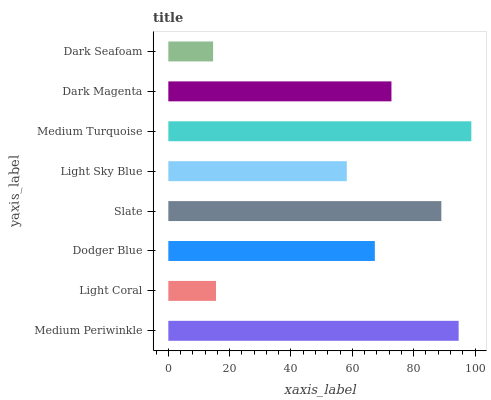Is Dark Seafoam the minimum?
Answer yes or no. Yes. Is Medium Turquoise the maximum?
Answer yes or no. Yes. Is Light Coral the minimum?
Answer yes or no. No. Is Light Coral the maximum?
Answer yes or no. No. Is Medium Periwinkle greater than Light Coral?
Answer yes or no. Yes. Is Light Coral less than Medium Periwinkle?
Answer yes or no. Yes. Is Light Coral greater than Medium Periwinkle?
Answer yes or no. No. Is Medium Periwinkle less than Light Coral?
Answer yes or no. No. Is Dark Magenta the high median?
Answer yes or no. Yes. Is Dodger Blue the low median?
Answer yes or no. Yes. Is Light Sky Blue the high median?
Answer yes or no. No. Is Medium Turquoise the low median?
Answer yes or no. No. 